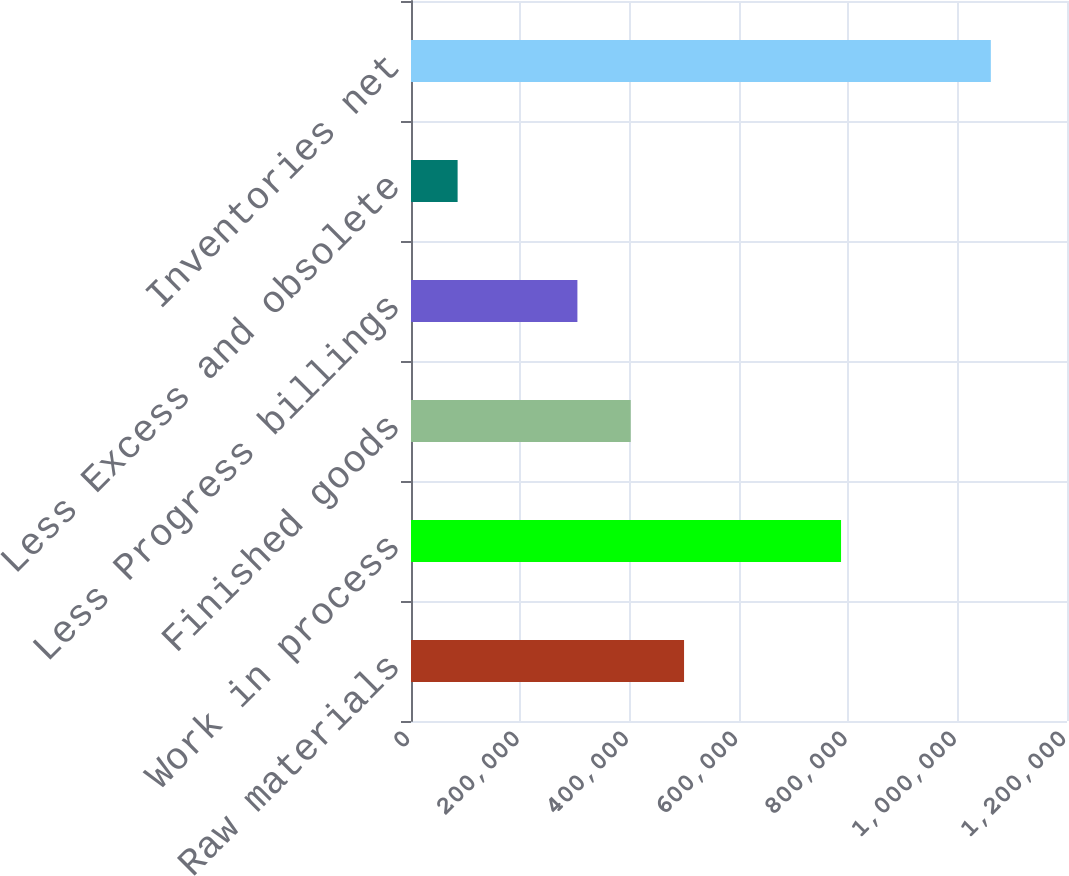Convert chart. <chart><loc_0><loc_0><loc_500><loc_500><bar_chart><fcel>Raw materials<fcel>Work in process<fcel>Finished goods<fcel>Less Progress billings<fcel>Less Excess and obsolete<fcel>Inventories net<nl><fcel>499476<fcel>786664<fcel>401936<fcel>304395<fcel>85263<fcel>1.06067e+06<nl></chart> 